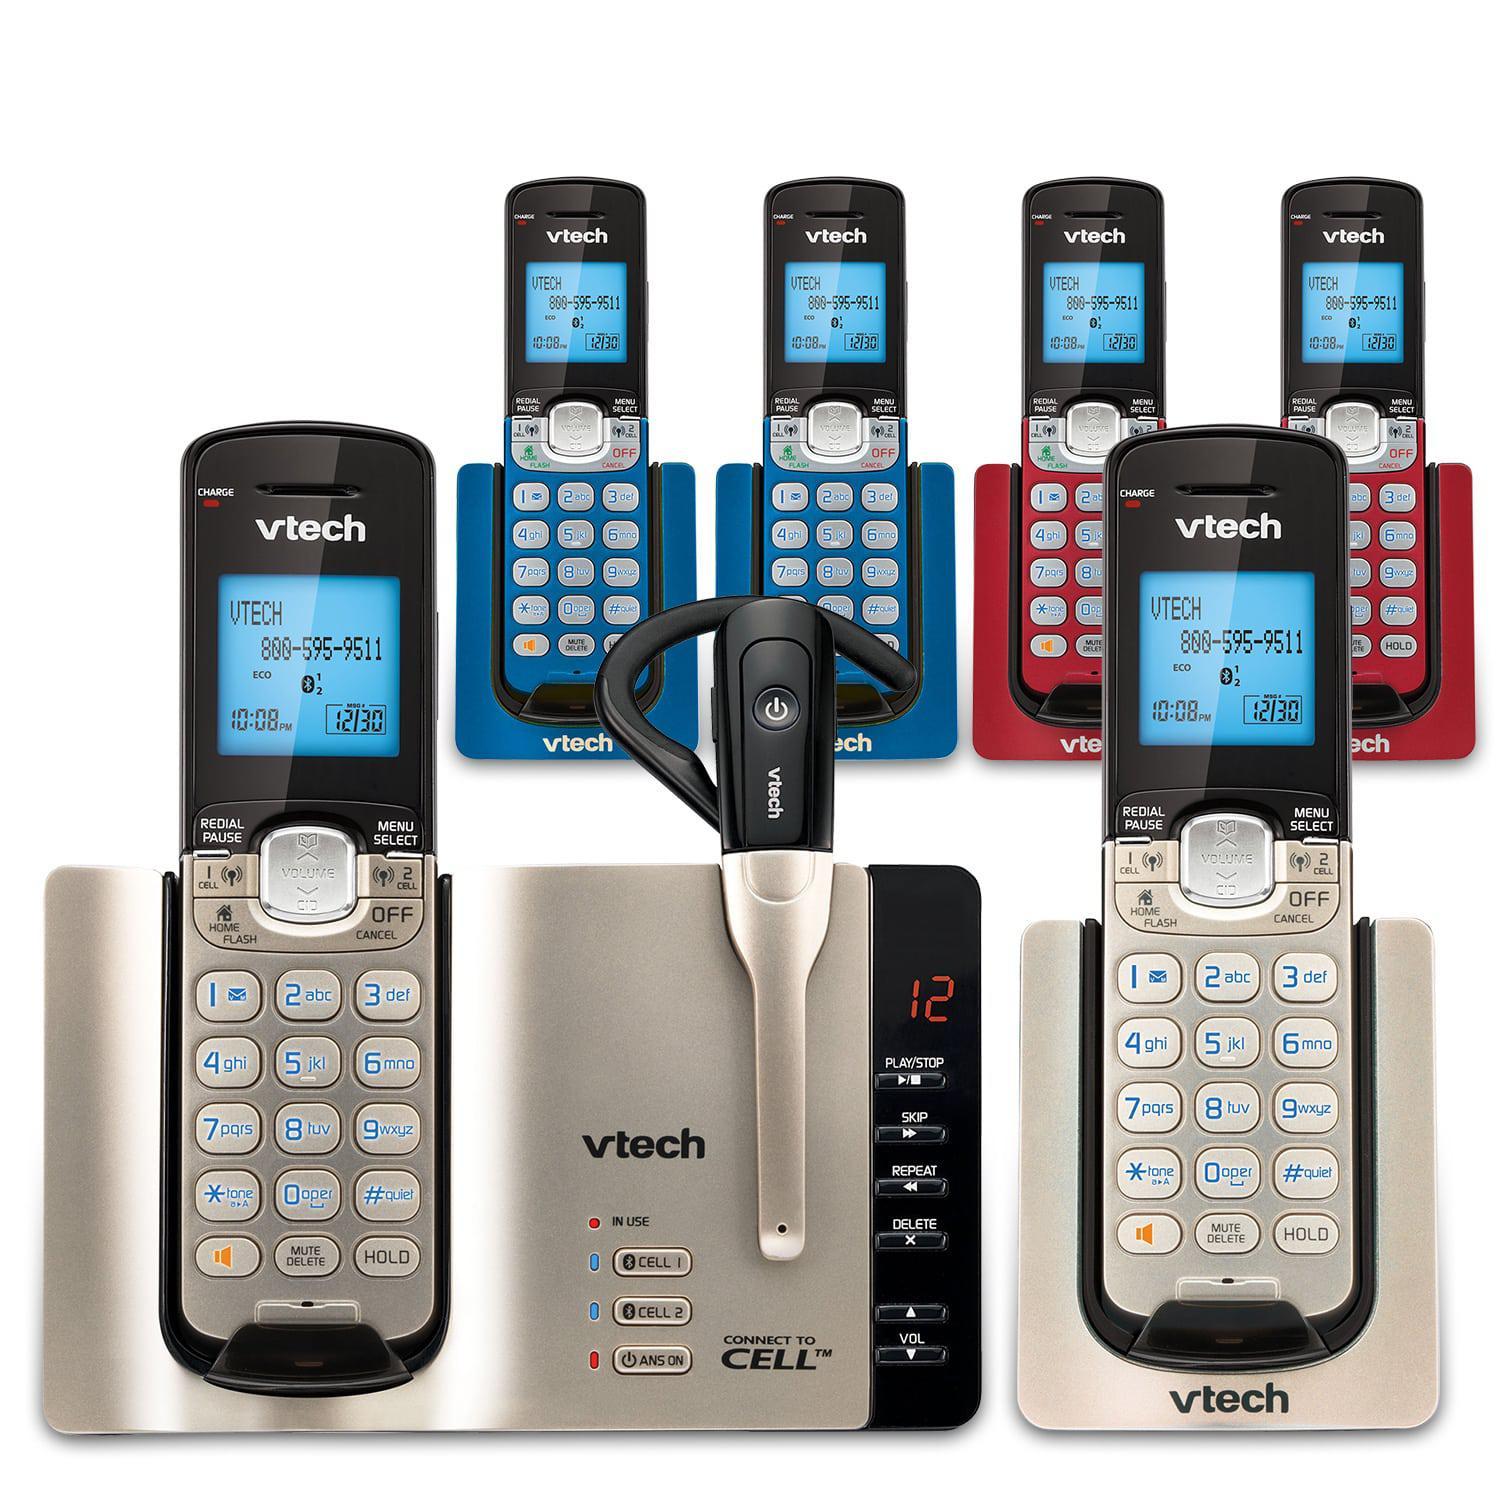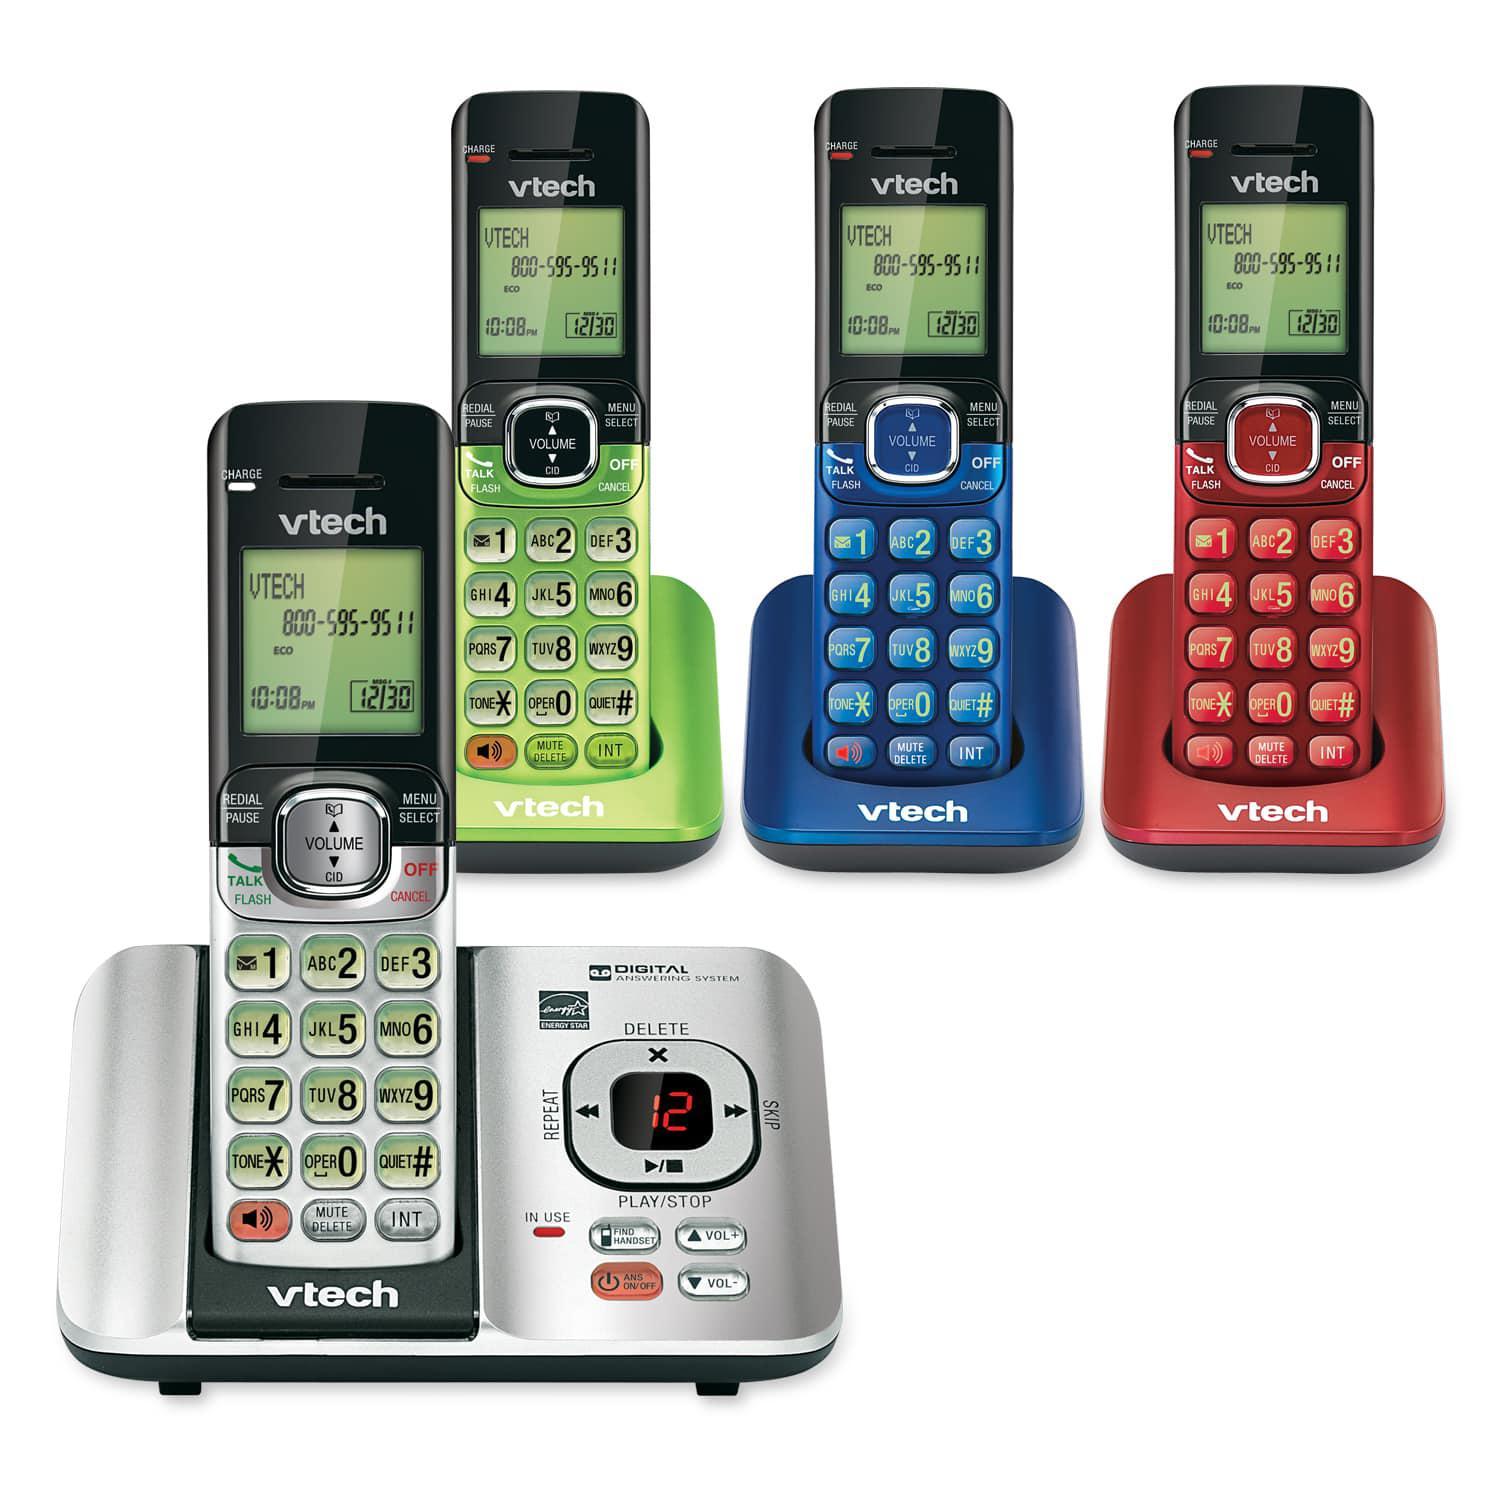The first image is the image on the left, the second image is the image on the right. Examine the images to the left and right. Is the description "Each image includes at least three 'extra' handsets resting in their bases and at least one main handset on a larger base." accurate? Answer yes or no. Yes. 